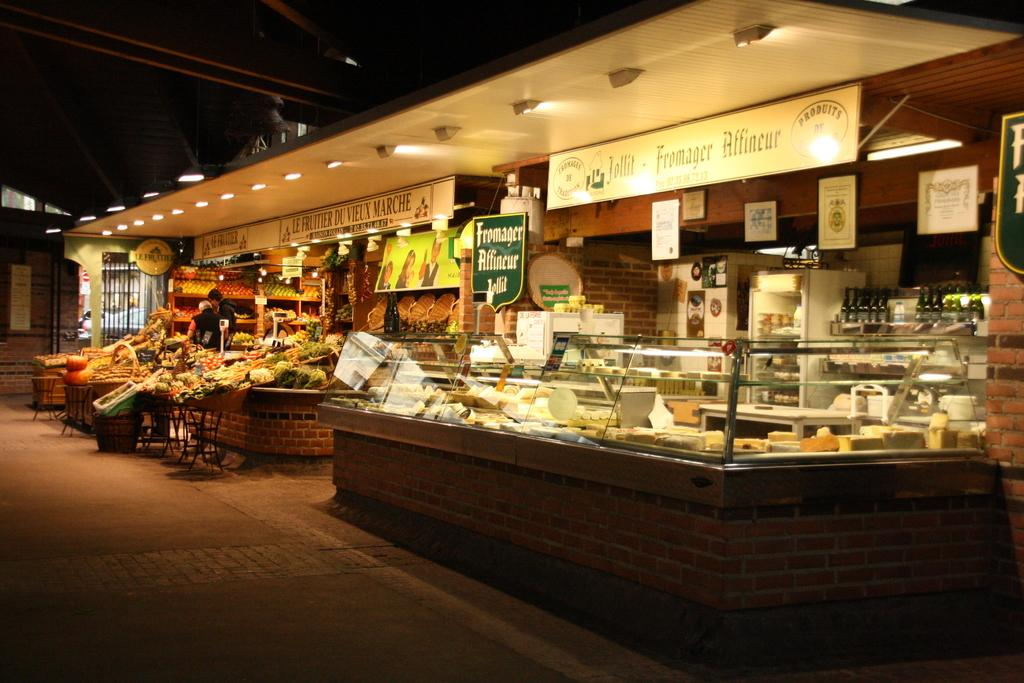How many people are in the image? There are two persons standing in the middle of the image. What can be seen in the background of the image? There are food stores visible in the background. Are there any additional elements in the image besides the people? Yes, there are banners present in the image. What is the structure of the image? The image has a roof at the top. What can be seen near the roof of the image? Lights are visible at the top of the image. What type of title can be seen on the banners in the image? There is no title visible on the banners in the image. How many dogs are present in the image? There are no dogs present in the image. 